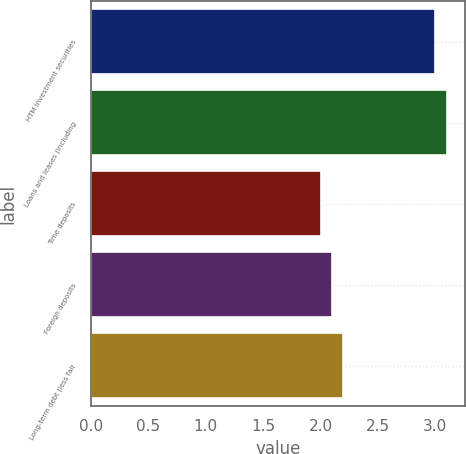<chart> <loc_0><loc_0><loc_500><loc_500><bar_chart><fcel>HTM investment securities<fcel>Loans and leases (including<fcel>Time deposits<fcel>Foreign deposits<fcel>Long-term debt (less fair<nl><fcel>3<fcel>3.1<fcel>2<fcel>2.1<fcel>2.2<nl></chart> 